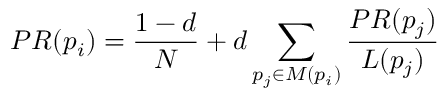<formula> <loc_0><loc_0><loc_500><loc_500>P R ( p _ { i } ) = { \frac { 1 - d } { N } } + d \sum _ { p _ { j } \in M ( p _ { i } ) } { \frac { P R ( p _ { j } ) } { L ( p _ { j } ) } }</formula> 